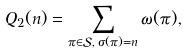<formula> <loc_0><loc_0><loc_500><loc_500>Q _ { 2 } ( n ) = \sum _ { \pi \in \mathcal { S } , \, \sigma ( \pi ) = n } \omega ( \pi ) ,</formula> 